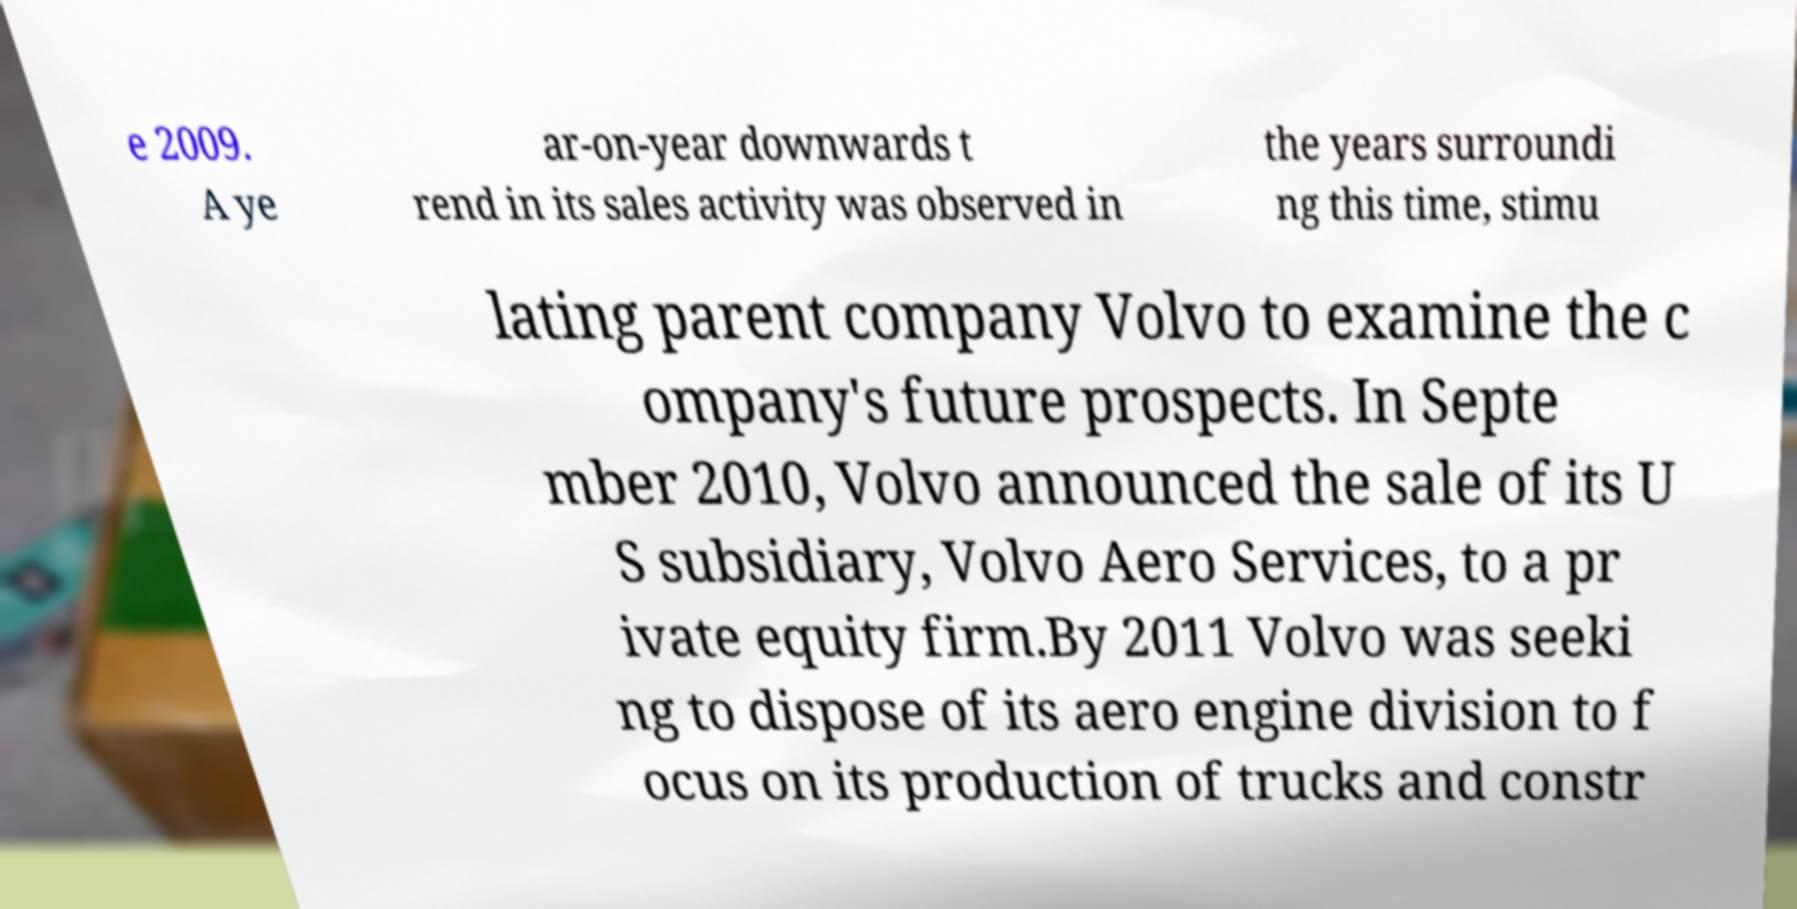What messages or text are displayed in this image? I need them in a readable, typed format. e 2009. A ye ar-on-year downwards t rend in its sales activity was observed in the years surroundi ng this time, stimu lating parent company Volvo to examine the c ompany's future prospects. In Septe mber 2010, Volvo announced the sale of its U S subsidiary, Volvo Aero Services, to a pr ivate equity firm.By 2011 Volvo was seeki ng to dispose of its aero engine division to f ocus on its production of trucks and constr 